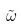Convert formula to latex. <formula><loc_0><loc_0><loc_500><loc_500>\tilde { \omega }</formula> 